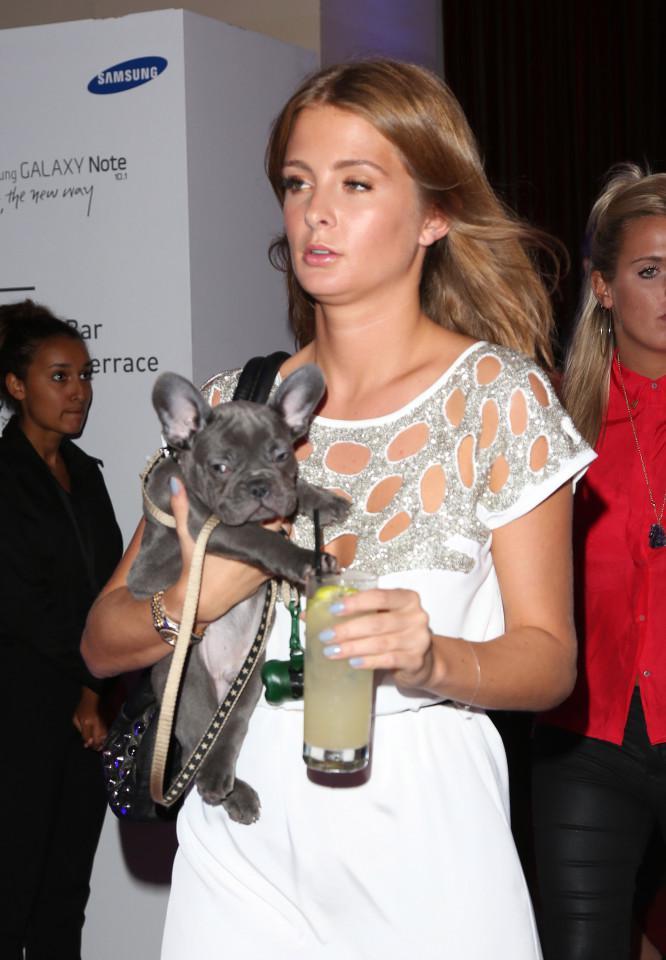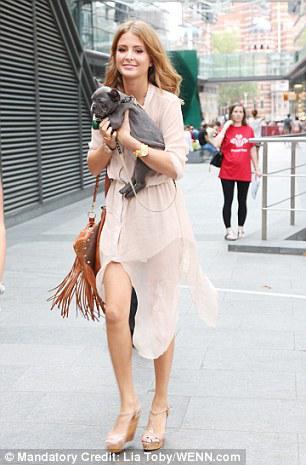The first image is the image on the left, the second image is the image on the right. Examine the images to the left and right. Is the description "Each image shows just one woman standing with an arm around a dark gray bulldog, and the same woman is shown in both images." accurate? Answer yes or no. Yes. 